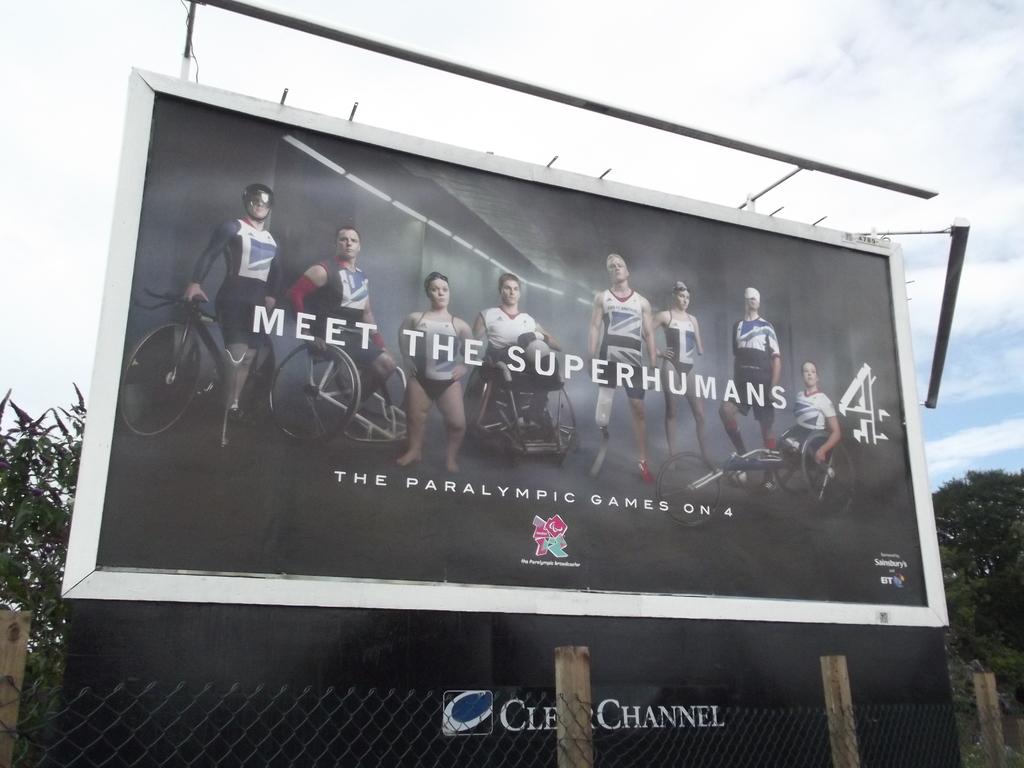Who are we meeting in the billboard?
Offer a terse response. Superhumans. 